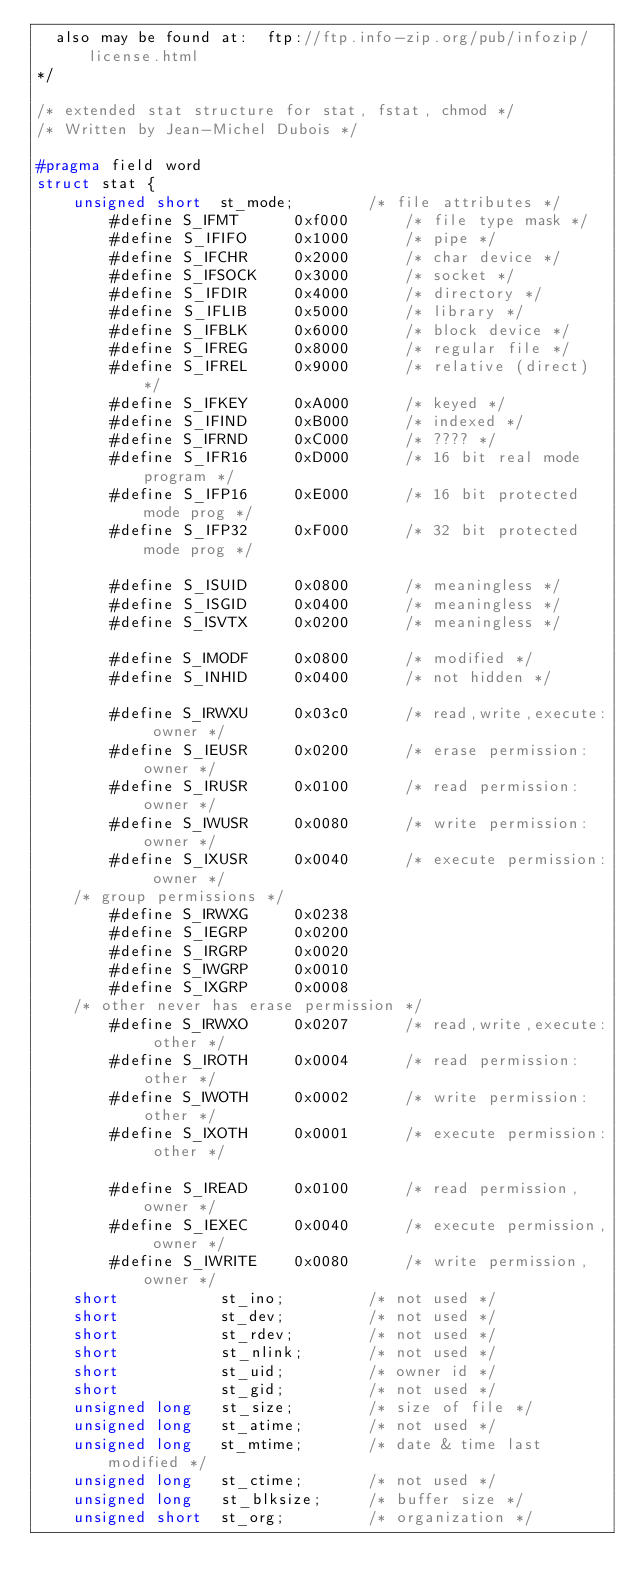Convert code to text. <code><loc_0><loc_0><loc_500><loc_500><_C_>  also may be found at:  ftp://ftp.info-zip.org/pub/infozip/license.html
*/

/* extended stat structure for stat, fstat, chmod */
/* Written by Jean-Michel Dubois */

#pragma field word
struct stat {
    unsigned short  st_mode;        /* file attributes */
        #define S_IFMT      0xf000      /* file type mask */
        #define S_IFIFO     0x1000      /* pipe */
        #define S_IFCHR     0x2000      /* char device */
        #define S_IFSOCK    0x3000      /* socket */
        #define S_IFDIR     0x4000      /* directory */
        #define S_IFLIB     0x5000      /* library */
        #define S_IFBLK     0x6000      /* block device */
        #define S_IFREG     0x8000      /* regular file */
        #define S_IFREL     0x9000      /* relative (direct) */
        #define S_IFKEY     0xA000      /* keyed */
        #define S_IFIND     0xB000      /* indexed */
        #define S_IFRND     0xC000      /* ???? */
        #define S_IFR16     0xD000      /* 16 bit real mode program */
        #define S_IFP16     0xE000      /* 16 bit protected mode prog */
        #define S_IFP32     0xF000      /* 32 bit protected mode prog */

        #define S_ISUID     0x0800      /* meaningless */
        #define S_ISGID     0x0400      /* meaningless */
        #define S_ISVTX     0x0200      /* meaningless */

        #define S_IMODF     0x0800      /* modified */
        #define S_INHID     0x0400      /* not hidden */

        #define S_IRWXU     0x03c0      /* read,write,execute: owner */
        #define S_IEUSR     0x0200      /* erase permission: owner */
        #define S_IRUSR     0x0100      /* read permission: owner */
        #define S_IWUSR     0x0080      /* write permission: owner */
        #define S_IXUSR     0x0040      /* execute permission: owner */
    /* group permissions */
        #define S_IRWXG     0x0238
        #define S_IEGRP     0x0200
        #define S_IRGRP     0x0020
        #define S_IWGRP     0x0010
        #define S_IXGRP     0x0008
    /* other never has erase permission */
        #define S_IRWXO     0x0207      /* read,write,execute: other */
        #define S_IROTH     0x0004      /* read permission: other */
        #define S_IWOTH     0x0002      /* write permission: other */
        #define S_IXOTH     0x0001      /* execute permission: other */

        #define S_IREAD     0x0100      /* read permission, owner */
        #define S_IEXEC     0x0040      /* execute permission, owner */
        #define S_IWRITE    0x0080      /* write permission, owner */
    short           st_ino;         /* not used */
    short           st_dev;         /* not used */
    short           st_rdev;        /* not used */
    short           st_nlink;       /* not used */
    short           st_uid;         /* owner id */
    short           st_gid;         /* not used */
    unsigned long   st_size;        /* size of file */
    unsigned long   st_atime;       /* not used */
    unsigned long   st_mtime;       /* date & time last modified */
    unsigned long   st_ctime;       /* not used */
    unsigned long   st_blksize;     /* buffer size */
    unsigned short  st_org;         /* organization */</code> 